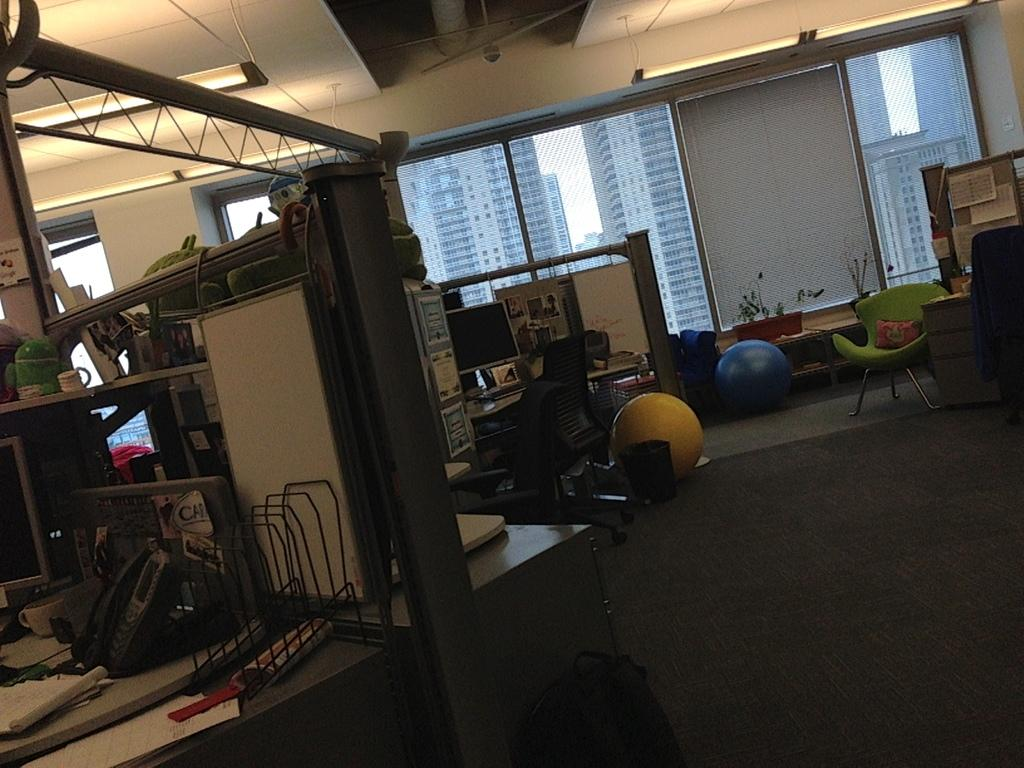What is on the table in the image? There are objects on the table in the image. What is on the floor in the image? There are objects on the floor in the image. What can be seen in the distance in the image? There are buildings visible in the background. What is at the top of the image? There are lights at the top of the image. What type of leather is being used by the doctor in the harbor in the image? There is no doctor, leather, or harbor present in the image. 